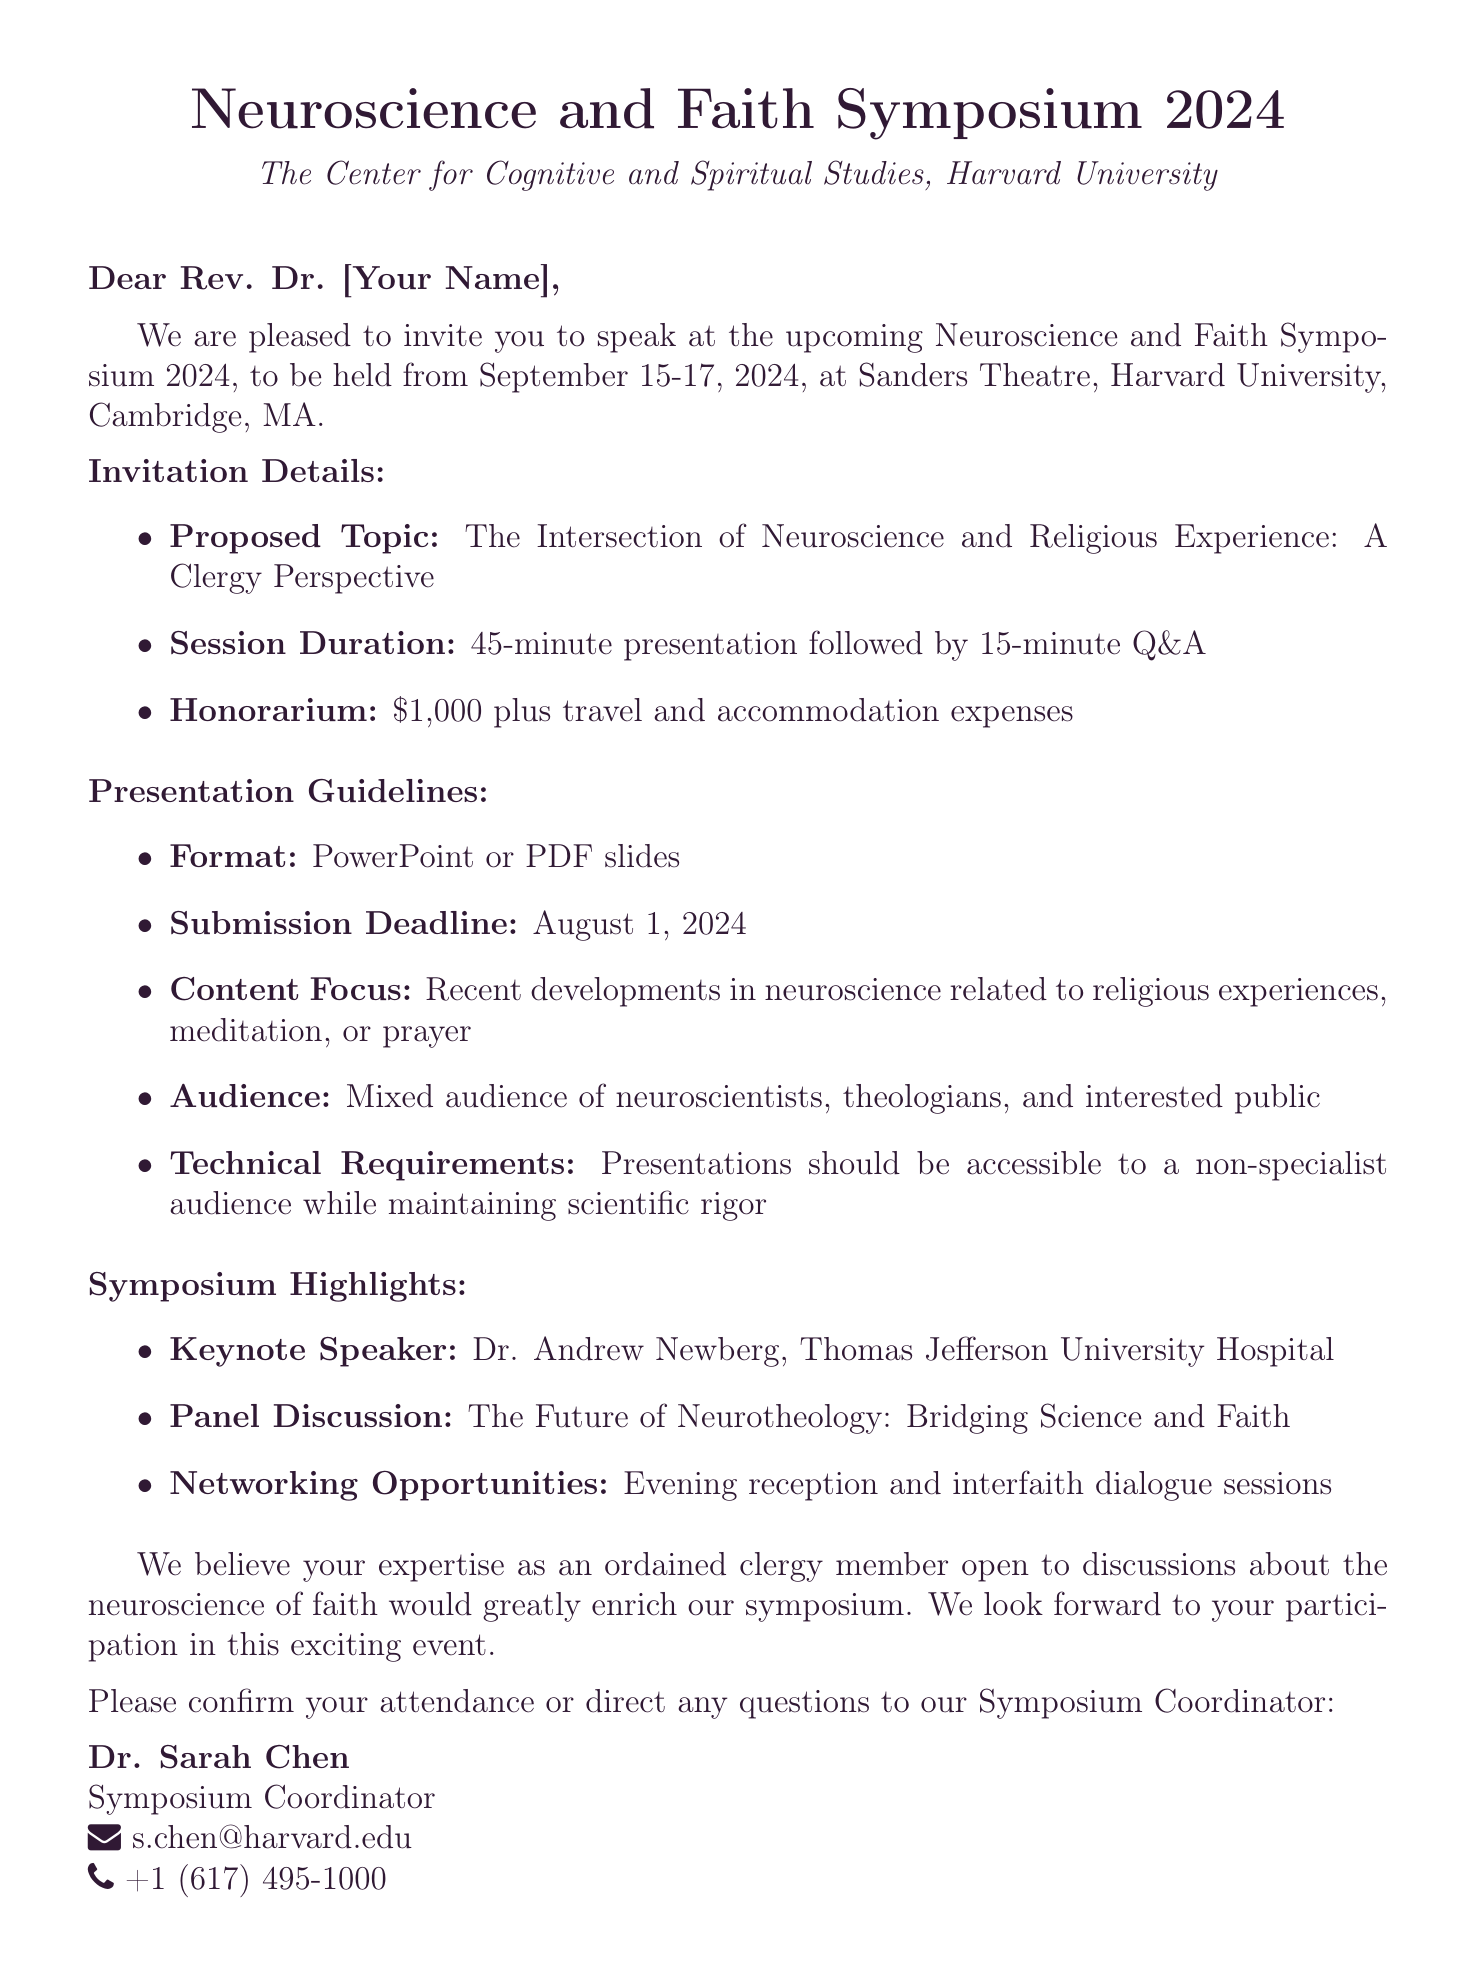What is the name of the symposium? The symposium is titled "Neuroscience and Faith Symposium 2024."
Answer: Neuroscience and Faith Symposium 2024 Who is organizing the event? The event is organized by "The Center for Cognitive and Spiritual Studies, Harvard University."
Answer: The Center for Cognitive and Spiritual Studies, Harvard University What are the dates of the symposium? The symposium will take place from September 15-17, 2024.
Answer: September 15-17, 2024 What is the proposed topic for the presentation? The proposed topic is "The Intersection of Neuroscience and Religious Experience: A Clergy Perspective."
Answer: The Intersection of Neuroscience and Religious Experience: A Clergy Perspective What is the honorarium for the speaker? The honorarium offered is $1,000 plus travel and accommodation expenses.
Answer: $1,000 plus travel and accommodation expenses What is the submission deadline for the presentation? The submission deadline for the presentation slides is August 1, 2024.
Answer: August 1, 2024 Who is the keynote speaker at the symposium? The keynote speaker is Dr. Andrew Newberg from Thomas Jefferson University Hospital.
Answer: Dr. Andrew Newberg, Thomas Jefferson University Hospital What type of audience will attend the symposium? The audience will be a mixed group of neuroscientists, theologians, and the interested public.
Answer: Mixed audience of neuroscientists, theologians, and interested public Where is the symposium located? The symposium will be held at Sanders Theatre, Harvard University, Cambridge, MA.
Answer: Sanders Theatre, Harvard University, Cambridge, MA 